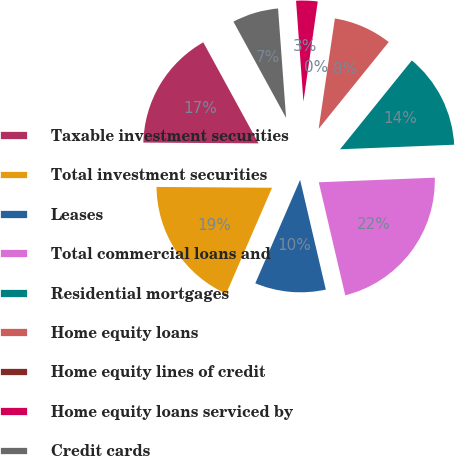<chart> <loc_0><loc_0><loc_500><loc_500><pie_chart><fcel>Taxable investment securities<fcel>Total investment securities<fcel>Leases<fcel>Total commercial loans and<fcel>Residential mortgages<fcel>Home equity loans<fcel>Home equity lines of credit<fcel>Home equity loans serviced by<fcel>Credit cards<nl><fcel>16.92%<fcel>18.6%<fcel>10.17%<fcel>21.97%<fcel>13.55%<fcel>8.49%<fcel>0.06%<fcel>3.43%<fcel>6.8%<nl></chart> 